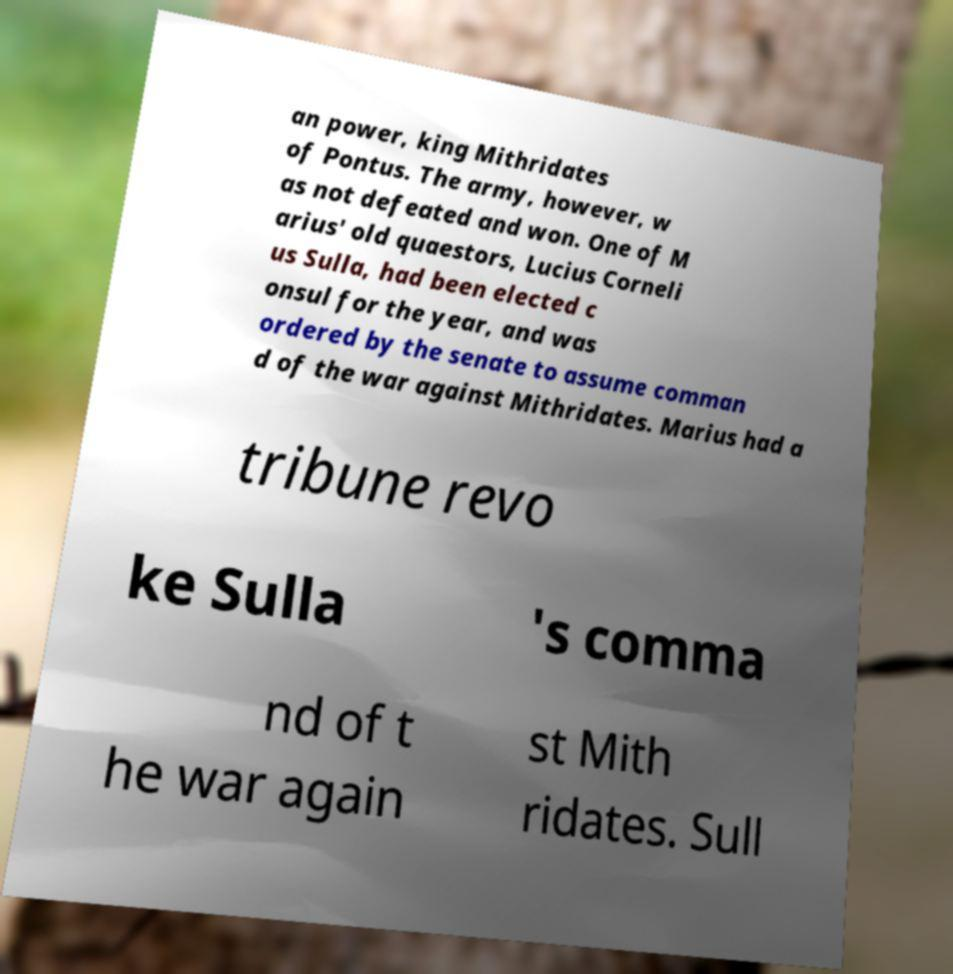For documentation purposes, I need the text within this image transcribed. Could you provide that? an power, king Mithridates of Pontus. The army, however, w as not defeated and won. One of M arius' old quaestors, Lucius Corneli us Sulla, had been elected c onsul for the year, and was ordered by the senate to assume comman d of the war against Mithridates. Marius had a tribune revo ke Sulla 's comma nd of t he war again st Mith ridates. Sull 